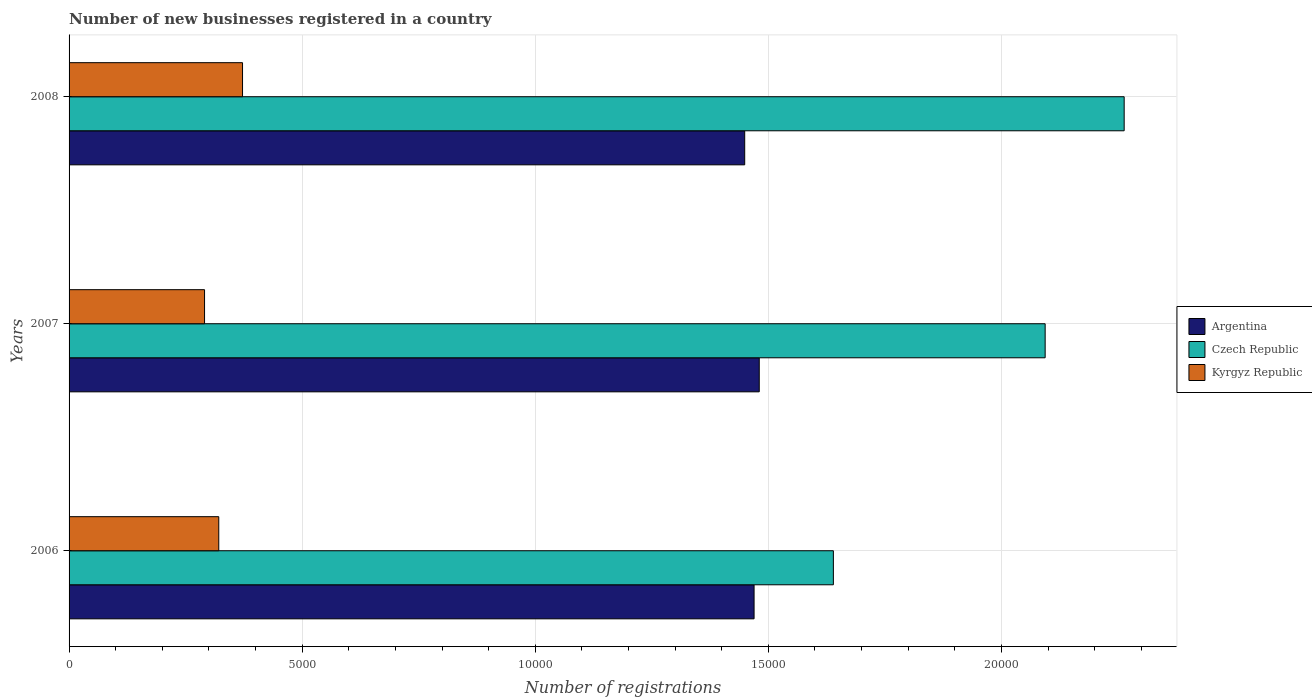Are the number of bars per tick equal to the number of legend labels?
Provide a succinct answer. Yes. Are the number of bars on each tick of the Y-axis equal?
Offer a very short reply. Yes. How many bars are there on the 3rd tick from the bottom?
Offer a terse response. 3. What is the number of new businesses registered in Argentina in 2008?
Provide a succinct answer. 1.45e+04. Across all years, what is the maximum number of new businesses registered in Kyrgyz Republic?
Offer a very short reply. 3721. Across all years, what is the minimum number of new businesses registered in Argentina?
Ensure brevity in your answer.  1.45e+04. In which year was the number of new businesses registered in Czech Republic maximum?
Provide a short and direct response. 2008. In which year was the number of new businesses registered in Kyrgyz Republic minimum?
Your response must be concise. 2007. What is the total number of new businesses registered in Czech Republic in the graph?
Provide a short and direct response. 6.00e+04. What is the difference between the number of new businesses registered in Argentina in 2007 and that in 2008?
Keep it short and to the point. 312. What is the difference between the number of new businesses registered in Czech Republic in 2006 and the number of new businesses registered in Argentina in 2008?
Provide a short and direct response. 1902. What is the average number of new businesses registered in Argentina per year?
Offer a terse response. 1.47e+04. In the year 2006, what is the difference between the number of new businesses registered in Czech Republic and number of new businesses registered in Kyrgyz Republic?
Ensure brevity in your answer.  1.32e+04. In how many years, is the number of new businesses registered in Kyrgyz Republic greater than 6000 ?
Your response must be concise. 0. What is the ratio of the number of new businesses registered in Kyrgyz Republic in 2006 to that in 2008?
Provide a succinct answer. 0.86. Is the difference between the number of new businesses registered in Czech Republic in 2006 and 2008 greater than the difference between the number of new businesses registered in Kyrgyz Republic in 2006 and 2008?
Ensure brevity in your answer.  No. What is the difference between the highest and the second highest number of new businesses registered in Czech Republic?
Give a very brief answer. 1695. What is the difference between the highest and the lowest number of new businesses registered in Czech Republic?
Give a very brief answer. 6238. Is the sum of the number of new businesses registered in Czech Republic in 2006 and 2008 greater than the maximum number of new businesses registered in Kyrgyz Republic across all years?
Offer a terse response. Yes. What does the 1st bar from the top in 2006 represents?
Your response must be concise. Kyrgyz Republic. What does the 1st bar from the bottom in 2007 represents?
Make the answer very short. Argentina. Are all the bars in the graph horizontal?
Give a very brief answer. Yes. How many years are there in the graph?
Keep it short and to the point. 3. What is the difference between two consecutive major ticks on the X-axis?
Make the answer very short. 5000. Does the graph contain any zero values?
Keep it short and to the point. No. Where does the legend appear in the graph?
Give a very brief answer. Center right. How many legend labels are there?
Offer a very short reply. 3. What is the title of the graph?
Provide a short and direct response. Number of new businesses registered in a country. Does "Tajikistan" appear as one of the legend labels in the graph?
Make the answer very short. No. What is the label or title of the X-axis?
Your response must be concise. Number of registrations. What is the Number of registrations of Argentina in 2006?
Provide a short and direct response. 1.47e+04. What is the Number of registrations of Czech Republic in 2006?
Make the answer very short. 1.64e+04. What is the Number of registrations of Kyrgyz Republic in 2006?
Your answer should be compact. 3211. What is the Number of registrations in Argentina in 2007?
Your response must be concise. 1.48e+04. What is the Number of registrations in Czech Republic in 2007?
Give a very brief answer. 2.09e+04. What is the Number of registrations of Kyrgyz Republic in 2007?
Your answer should be compact. 2906. What is the Number of registrations of Argentina in 2008?
Your answer should be compact. 1.45e+04. What is the Number of registrations of Czech Republic in 2008?
Provide a short and direct response. 2.26e+04. What is the Number of registrations in Kyrgyz Republic in 2008?
Ensure brevity in your answer.  3721. Across all years, what is the maximum Number of registrations in Argentina?
Your response must be concise. 1.48e+04. Across all years, what is the maximum Number of registrations in Czech Republic?
Offer a very short reply. 2.26e+04. Across all years, what is the maximum Number of registrations of Kyrgyz Republic?
Keep it short and to the point. 3721. Across all years, what is the minimum Number of registrations in Argentina?
Offer a very short reply. 1.45e+04. Across all years, what is the minimum Number of registrations in Czech Republic?
Make the answer very short. 1.64e+04. Across all years, what is the minimum Number of registrations in Kyrgyz Republic?
Offer a terse response. 2906. What is the total Number of registrations in Argentina in the graph?
Your answer should be compact. 4.40e+04. What is the total Number of registrations in Czech Republic in the graph?
Keep it short and to the point. 6.00e+04. What is the total Number of registrations in Kyrgyz Republic in the graph?
Give a very brief answer. 9838. What is the difference between the Number of registrations in Argentina in 2006 and that in 2007?
Offer a terse response. -111. What is the difference between the Number of registrations in Czech Republic in 2006 and that in 2007?
Provide a short and direct response. -4543. What is the difference between the Number of registrations in Kyrgyz Republic in 2006 and that in 2007?
Ensure brevity in your answer.  305. What is the difference between the Number of registrations in Argentina in 2006 and that in 2008?
Ensure brevity in your answer.  201. What is the difference between the Number of registrations of Czech Republic in 2006 and that in 2008?
Keep it short and to the point. -6238. What is the difference between the Number of registrations in Kyrgyz Republic in 2006 and that in 2008?
Your answer should be compact. -510. What is the difference between the Number of registrations of Argentina in 2007 and that in 2008?
Give a very brief answer. 312. What is the difference between the Number of registrations of Czech Republic in 2007 and that in 2008?
Offer a terse response. -1695. What is the difference between the Number of registrations in Kyrgyz Republic in 2007 and that in 2008?
Offer a terse response. -815. What is the difference between the Number of registrations of Argentina in 2006 and the Number of registrations of Czech Republic in 2007?
Keep it short and to the point. -6244. What is the difference between the Number of registrations of Argentina in 2006 and the Number of registrations of Kyrgyz Republic in 2007?
Ensure brevity in your answer.  1.18e+04. What is the difference between the Number of registrations of Czech Republic in 2006 and the Number of registrations of Kyrgyz Republic in 2007?
Your response must be concise. 1.35e+04. What is the difference between the Number of registrations in Argentina in 2006 and the Number of registrations in Czech Republic in 2008?
Ensure brevity in your answer.  -7939. What is the difference between the Number of registrations in Argentina in 2006 and the Number of registrations in Kyrgyz Republic in 2008?
Give a very brief answer. 1.10e+04. What is the difference between the Number of registrations in Czech Republic in 2006 and the Number of registrations in Kyrgyz Republic in 2008?
Your response must be concise. 1.27e+04. What is the difference between the Number of registrations of Argentina in 2007 and the Number of registrations of Czech Republic in 2008?
Keep it short and to the point. -7828. What is the difference between the Number of registrations of Argentina in 2007 and the Number of registrations of Kyrgyz Republic in 2008?
Your answer should be compact. 1.11e+04. What is the difference between the Number of registrations of Czech Republic in 2007 and the Number of registrations of Kyrgyz Republic in 2008?
Offer a very short reply. 1.72e+04. What is the average Number of registrations of Argentina per year?
Your answer should be very brief. 1.47e+04. What is the average Number of registrations in Czech Republic per year?
Provide a succinct answer. 2.00e+04. What is the average Number of registrations in Kyrgyz Republic per year?
Your response must be concise. 3279.33. In the year 2006, what is the difference between the Number of registrations of Argentina and Number of registrations of Czech Republic?
Offer a very short reply. -1701. In the year 2006, what is the difference between the Number of registrations in Argentina and Number of registrations in Kyrgyz Republic?
Your answer should be very brief. 1.15e+04. In the year 2006, what is the difference between the Number of registrations of Czech Republic and Number of registrations of Kyrgyz Republic?
Give a very brief answer. 1.32e+04. In the year 2007, what is the difference between the Number of registrations of Argentina and Number of registrations of Czech Republic?
Keep it short and to the point. -6133. In the year 2007, what is the difference between the Number of registrations of Argentina and Number of registrations of Kyrgyz Republic?
Offer a terse response. 1.19e+04. In the year 2007, what is the difference between the Number of registrations of Czech Republic and Number of registrations of Kyrgyz Republic?
Keep it short and to the point. 1.80e+04. In the year 2008, what is the difference between the Number of registrations of Argentina and Number of registrations of Czech Republic?
Offer a terse response. -8140. In the year 2008, what is the difference between the Number of registrations of Argentina and Number of registrations of Kyrgyz Republic?
Provide a succinct answer. 1.08e+04. In the year 2008, what is the difference between the Number of registrations in Czech Republic and Number of registrations in Kyrgyz Republic?
Your answer should be compact. 1.89e+04. What is the ratio of the Number of registrations of Argentina in 2006 to that in 2007?
Offer a terse response. 0.99. What is the ratio of the Number of registrations in Czech Republic in 2006 to that in 2007?
Offer a terse response. 0.78. What is the ratio of the Number of registrations of Kyrgyz Republic in 2006 to that in 2007?
Keep it short and to the point. 1.1. What is the ratio of the Number of registrations of Argentina in 2006 to that in 2008?
Provide a succinct answer. 1.01. What is the ratio of the Number of registrations in Czech Republic in 2006 to that in 2008?
Keep it short and to the point. 0.72. What is the ratio of the Number of registrations of Kyrgyz Republic in 2006 to that in 2008?
Ensure brevity in your answer.  0.86. What is the ratio of the Number of registrations of Argentina in 2007 to that in 2008?
Ensure brevity in your answer.  1.02. What is the ratio of the Number of registrations in Czech Republic in 2007 to that in 2008?
Your answer should be very brief. 0.93. What is the ratio of the Number of registrations of Kyrgyz Republic in 2007 to that in 2008?
Make the answer very short. 0.78. What is the difference between the highest and the second highest Number of registrations of Argentina?
Your answer should be compact. 111. What is the difference between the highest and the second highest Number of registrations of Czech Republic?
Offer a terse response. 1695. What is the difference between the highest and the second highest Number of registrations of Kyrgyz Republic?
Make the answer very short. 510. What is the difference between the highest and the lowest Number of registrations of Argentina?
Provide a succinct answer. 312. What is the difference between the highest and the lowest Number of registrations in Czech Republic?
Your answer should be compact. 6238. What is the difference between the highest and the lowest Number of registrations in Kyrgyz Republic?
Make the answer very short. 815. 